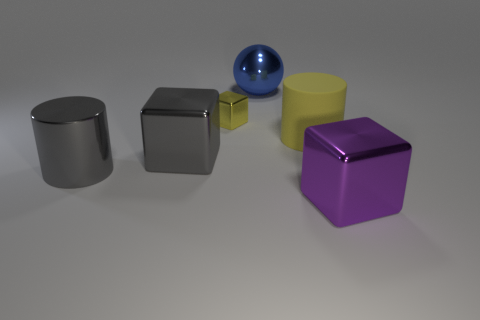Subtract all purple metallic cubes. How many cubes are left? 2 Subtract 1 cylinders. How many cylinders are left? 1 Add 2 big balls. How many objects exist? 8 Subtract all green cylinders. How many yellow spheres are left? 0 Add 2 tiny yellow cubes. How many tiny yellow cubes exist? 3 Subtract all yellow cylinders. How many cylinders are left? 1 Subtract 1 yellow cylinders. How many objects are left? 5 Subtract all spheres. How many objects are left? 5 Subtract all red spheres. Subtract all red cylinders. How many spheres are left? 1 Subtract all matte cylinders. Subtract all blue blocks. How many objects are left? 5 